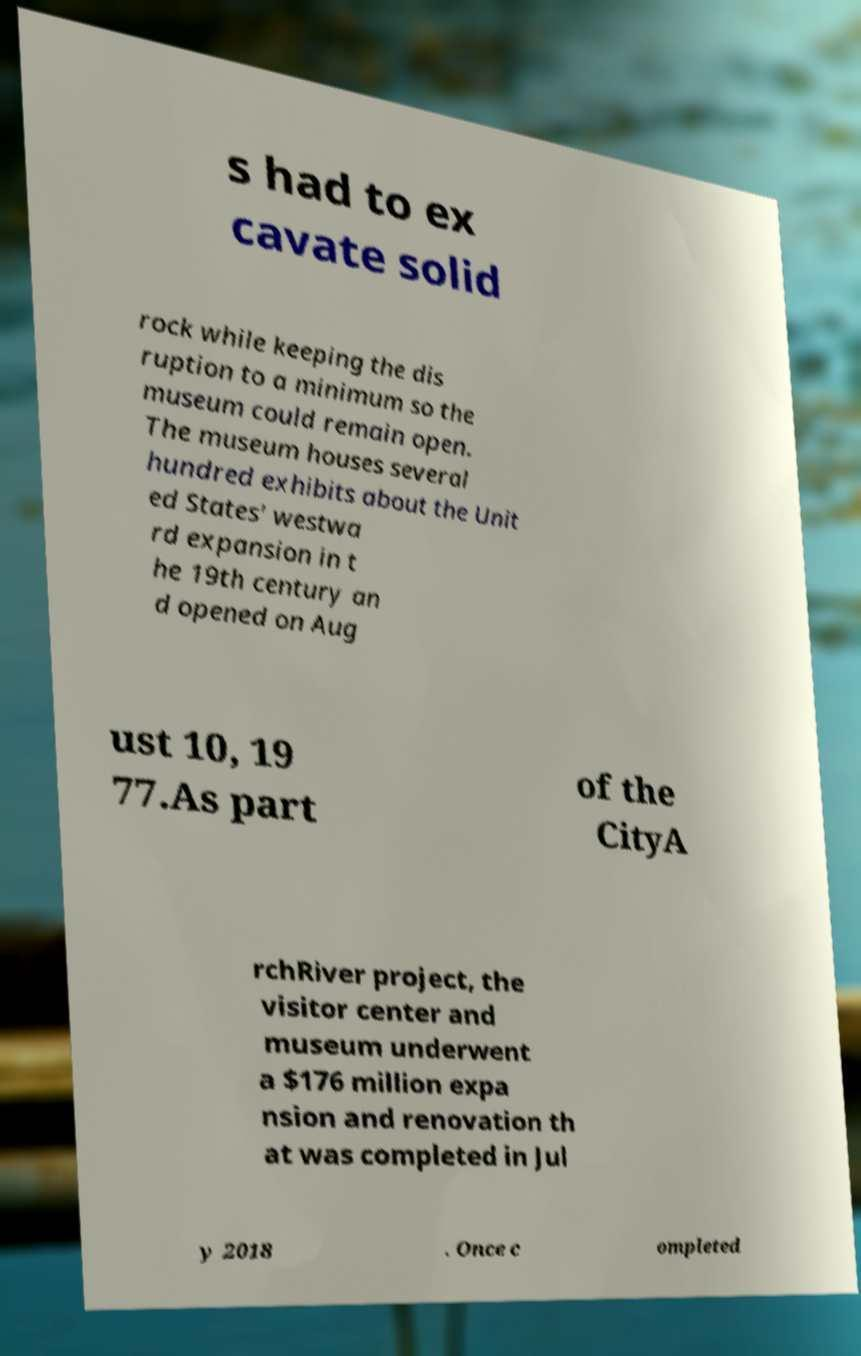Can you read and provide the text displayed in the image?This photo seems to have some interesting text. Can you extract and type it out for me? s had to ex cavate solid rock while keeping the dis ruption to a minimum so the museum could remain open. The museum houses several hundred exhibits about the Unit ed States' westwa rd expansion in t he 19th century an d opened on Aug ust 10, 19 77.As part of the CityA rchRiver project, the visitor center and museum underwent a $176 million expa nsion and renovation th at was completed in Jul y 2018 . Once c ompleted 